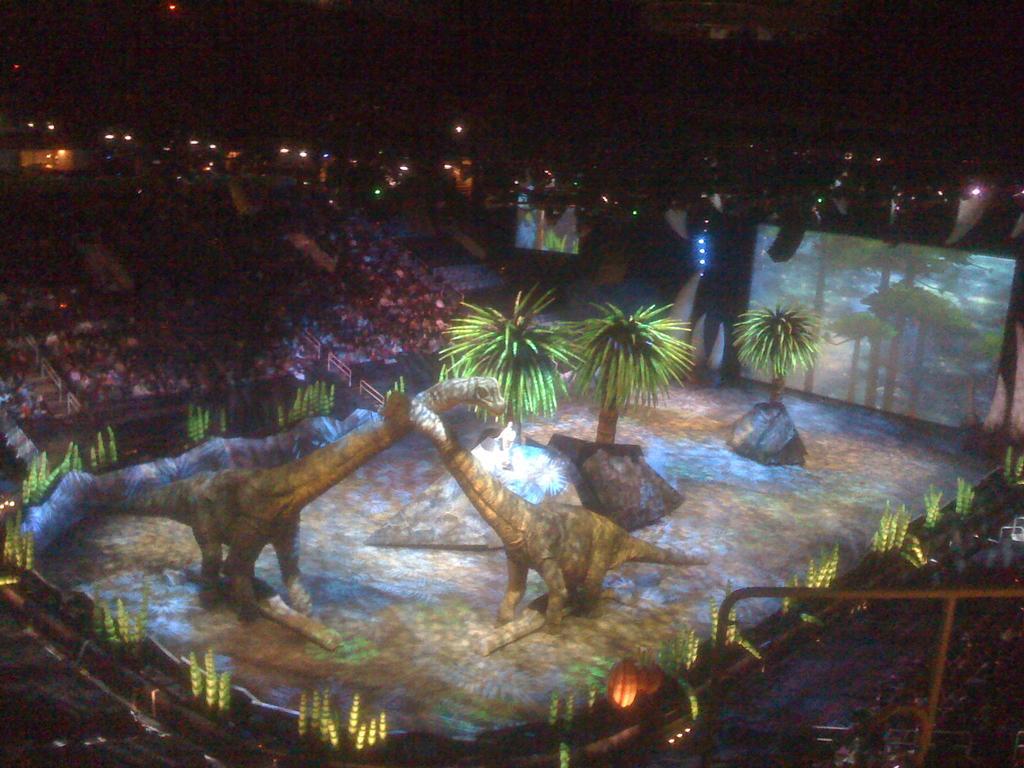Could you give a brief overview of what you see in this image? In this image there are animal statues. Behind there are trees and rocks. Right side there are screens. Top of the image lights are attached to the metal rods. Few lights are attached to the wall. Left side there are people on the stairs. 